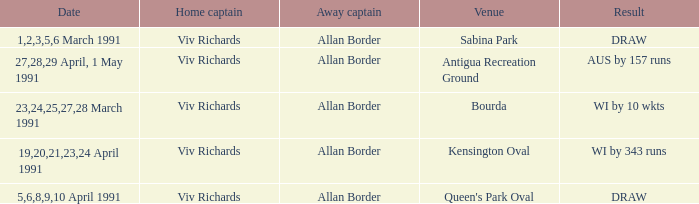Which venues resulted in a draw? Sabina Park, Queen's Park Oval. 